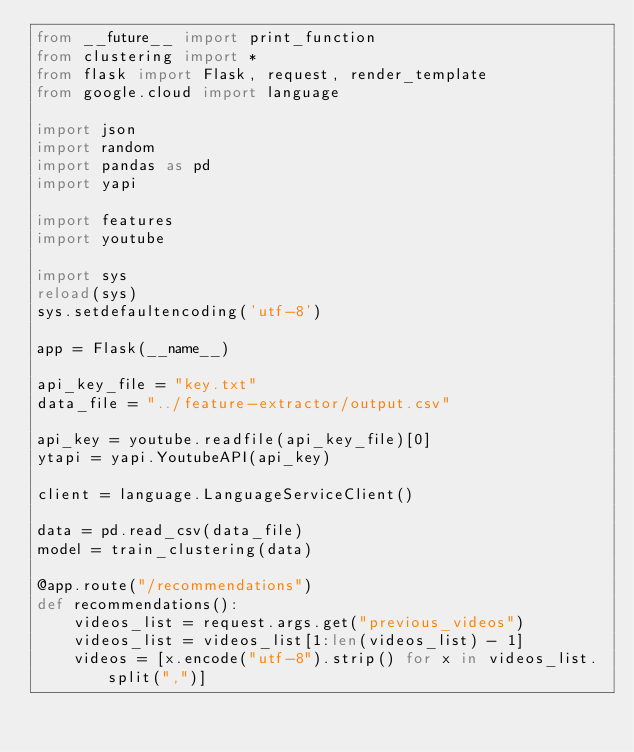Convert code to text. <code><loc_0><loc_0><loc_500><loc_500><_Python_>from __future__ import print_function
from clustering import *
from flask import Flask, request, render_template
from google.cloud import language

import json
import random
import pandas as pd
import yapi

import features
import youtube

import sys
reload(sys)
sys.setdefaultencoding('utf-8')

app = Flask(__name__)

api_key_file = "key.txt"
data_file = "../feature-extractor/output.csv"

api_key = youtube.readfile(api_key_file)[0]
ytapi = yapi.YoutubeAPI(api_key)

client = language.LanguageServiceClient()

data = pd.read_csv(data_file)
model = train_clustering(data)

@app.route("/recommendations")
def recommendations():
    videos_list = request.args.get("previous_videos")
    videos_list = videos_list[1:len(videos_list) - 1]
    videos = [x.encode("utf-8").strip() for x in videos_list.split(",")]
</code> 